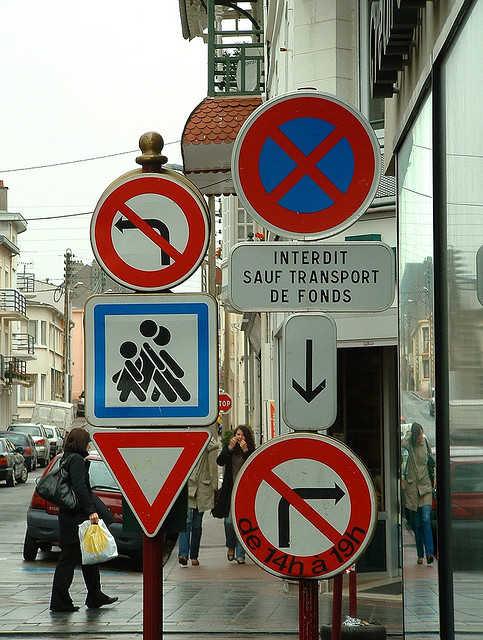Identify the text displayed in this image. INTERDIT SAUF TRANSPORT DE FONDS 19h a 14h de TOP 